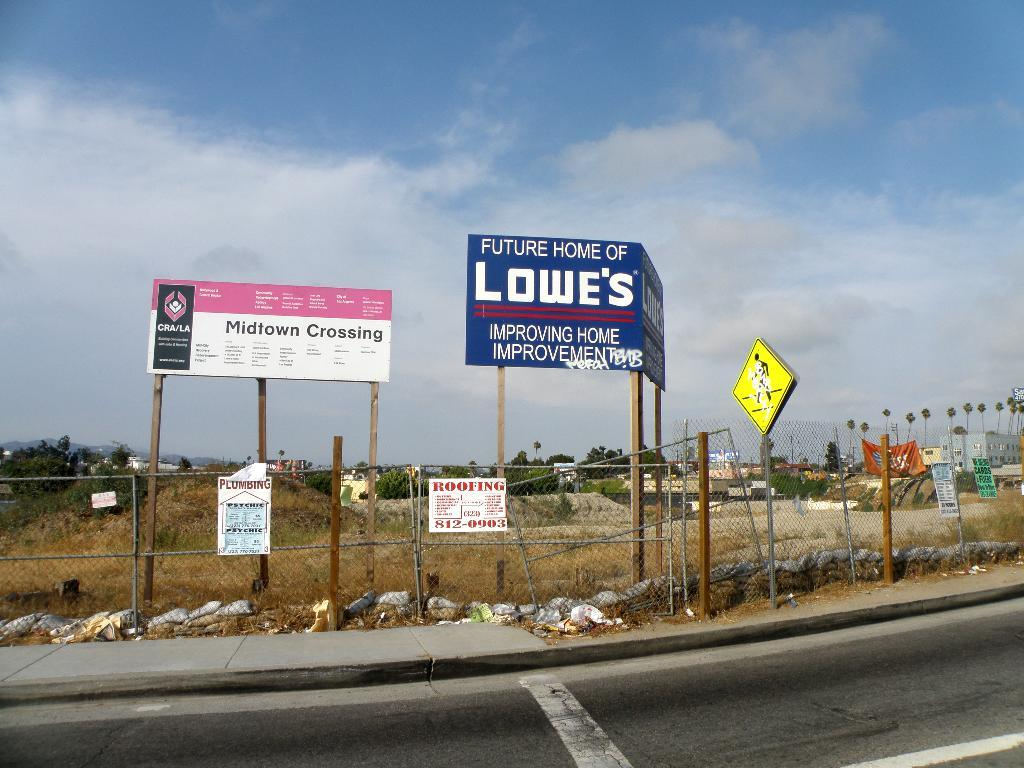<image>
Render a clear and concise summary of the photo. A blue sign indicates the future home of Lowe's. 